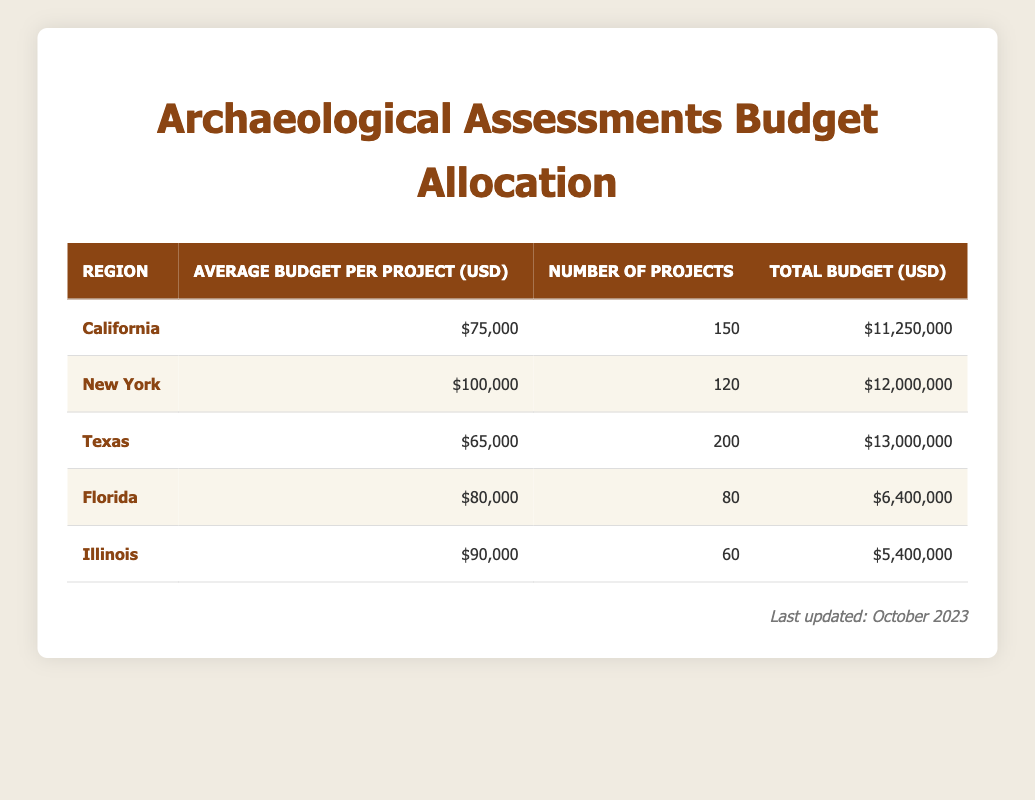What is the total budget for archaeological assessments in New York? The total budget for New York is specified in the table under the column for total budget, which shows $12,000,000.
Answer: 12,000,000 Which region has the highest average budget per project? The average budget per project is listed for each region, and by comparing these values, New York has the highest average budget of $100,000.
Answer: New York How much more is the total budget for Texas compared to Florida? The total budget for Texas is $13,000,000 and for Florida, it is $6,400,000. The difference is calculated as 13,000,000 - 6,400,000 = 6,600,000.
Answer: 6,600,000 Is the average budget per project in Illinois higher than that in Texas? The average budget per project in Illinois is $90,000 and in Texas is $65,000. Since 90,000 > 65,000, it confirms that Illinois has a higher average budget.
Answer: Yes What is the combined total budget for all projects in California and Florida? The total budget for California is $11,250,000 and for Florida is $6,400,000. The combined total is calculated as 11,250,000 + 6,400,000 = 17,650,000.
Answer: 17,650,000 How many total projects are there across all regions? The number of projects for each region is summed up: 150 (California) + 120 (New York) + 200 (Texas) + 80 (Florida) + 60 (Illinois) = 710.
Answer: 710 Is there a region where the average budget per project is less than $70,000? By reviewing the average budget per project values for each region, Texas has an average of $65,000, which is indeed less than $70,000.
Answer: Yes What is the overall average budget per project across all regions? The average budget per project is calculated by taking the total budgets for all regions (37,000,000) and dividing by the total number of projects (710), resulting in approximately $52,112.68.
Answer: 52,112.68 What region has the least number of projects? The table shows that Florida has the least number of projects at 80 when compared to the other regions.
Answer: Florida 